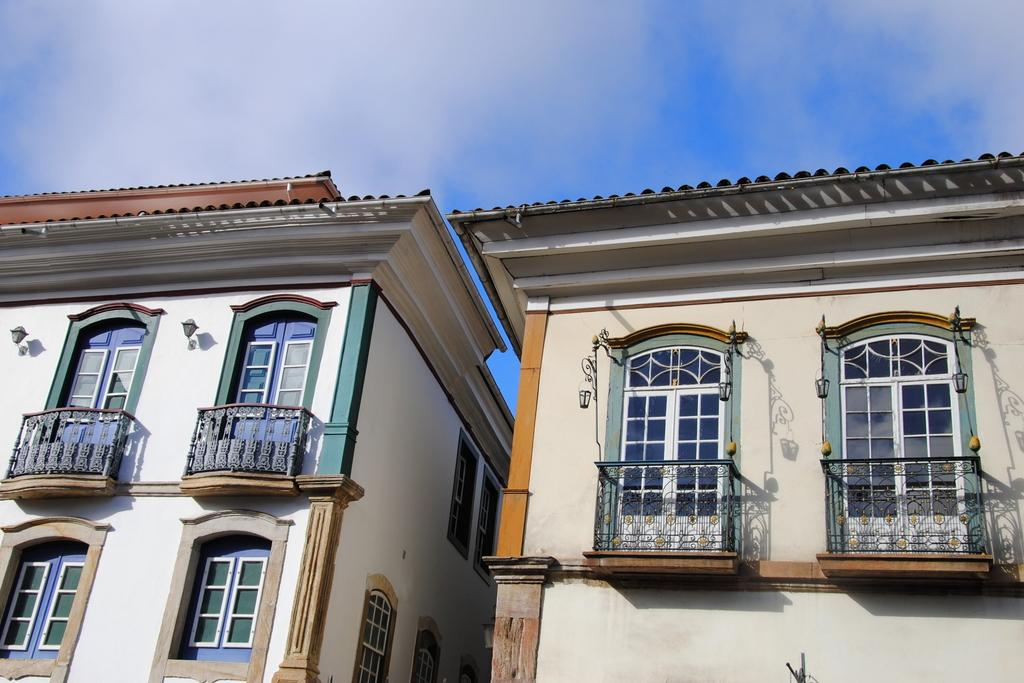What type of structures are visible in the image? There are buildings with windows in the image. What is the condition of the sky in the image? The sky is cloudy in the image. Where is the beef stored in the image? There is no beef present in the image. Are there any bears visible in the image? There are no bears visible in the image. Can you tell me if there is a cellar in any of the buildings shown in the image? The provided facts do not mention a cellar, so it cannot be determined from the image. 